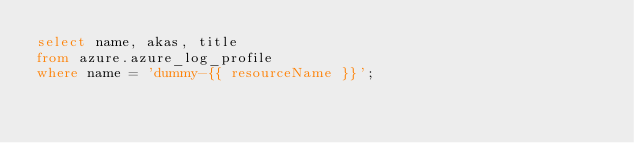<code> <loc_0><loc_0><loc_500><loc_500><_SQL_>select name, akas, title
from azure.azure_log_profile
where name = 'dummy-{{ resourceName }}';
</code> 